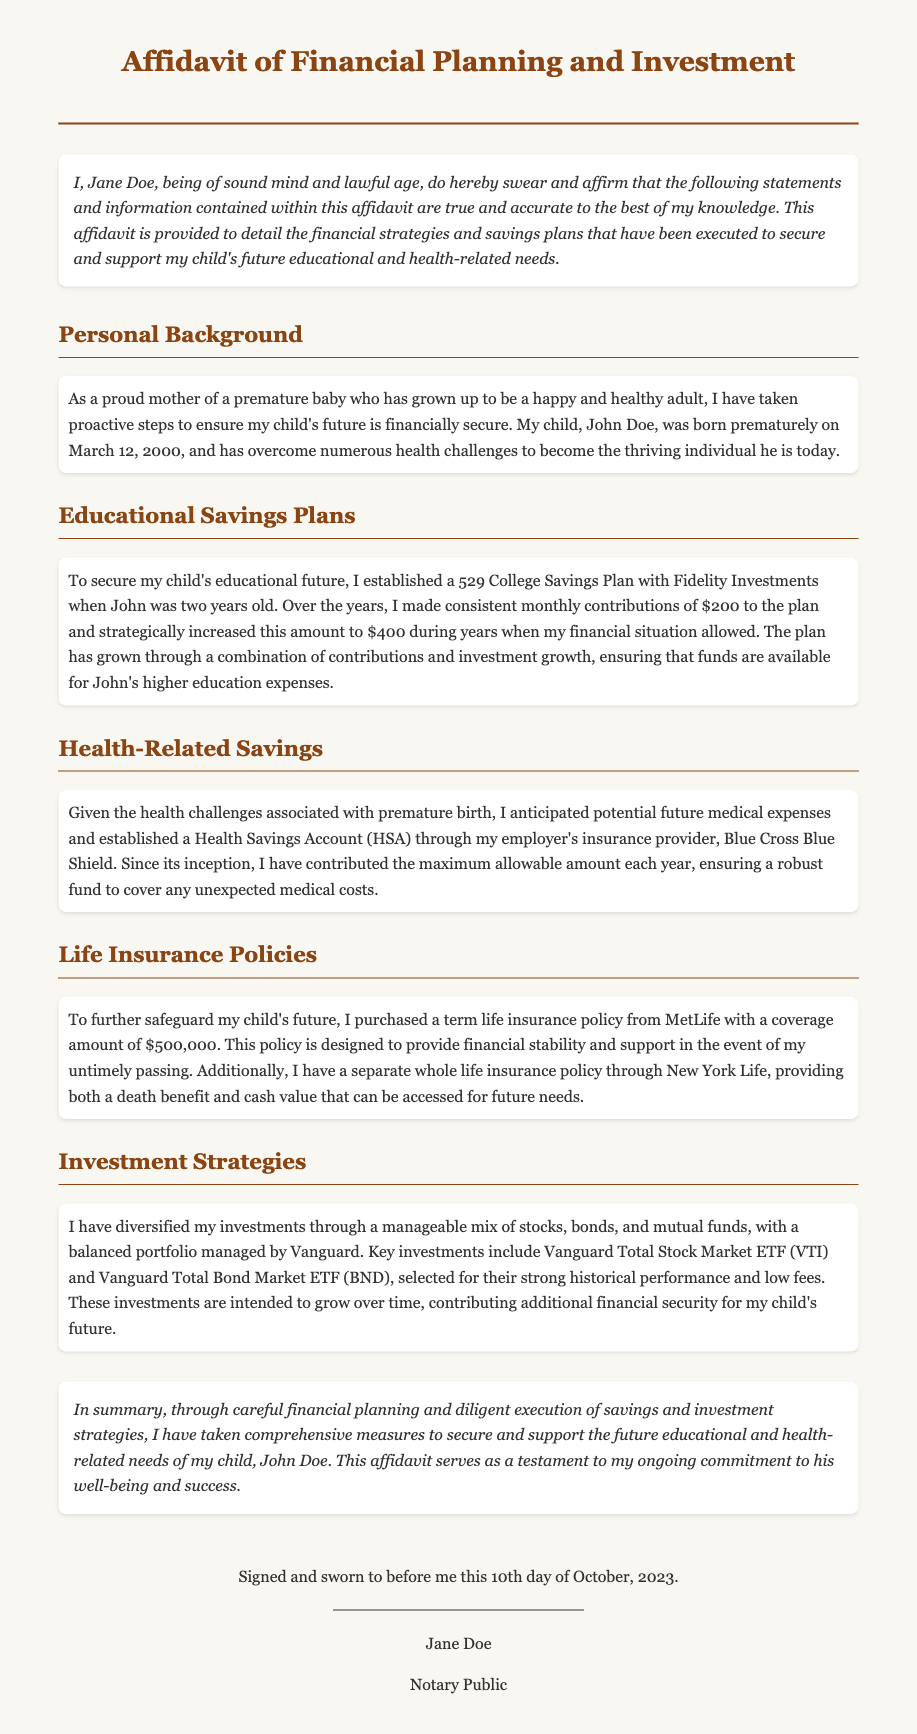What is the name of the child mentioned in the affidavit? The child's name is stated in the document as John Doe.
Answer: John Doe What type of savings plan was established for education? The document specifies that a 529 College Savings Plan was established.
Answer: 529 College Savings Plan How much was contributed monthly to the education savings plan? Monthly contributions to the plan started at $200 and increased during better financial situations.
Answer: $200 What organization manages the Health Savings Account? The Health Savings Account is established through Blue Cross Blue Shield.
Answer: Blue Cross Blue Shield What is the coverage amount of the term life insurance policy? The life insurance policy from MetLife has a coverage amount defined in the document.
Answer: $500,000 What investment company is mentioned for managing the diversified investments? The document specifies that Vanguard manages the diversified investments.
Answer: Vanguard How many years after birth was the 529 plan established? The 529 plan was established when John was two years old, which is two years after his birth.
Answer: Two years What type of life insurance provides both a death benefit and cash value? The document states that a whole life insurance policy provides both features.
Answer: Whole life insurance When was the affidavit signed? The document states that the affidavit was signed on the 10th day of October, 2023.
Answer: October 10, 2023 